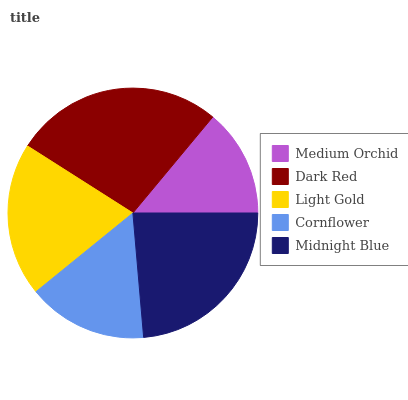Is Medium Orchid the minimum?
Answer yes or no. Yes. Is Dark Red the maximum?
Answer yes or no. Yes. Is Light Gold the minimum?
Answer yes or no. No. Is Light Gold the maximum?
Answer yes or no. No. Is Dark Red greater than Light Gold?
Answer yes or no. Yes. Is Light Gold less than Dark Red?
Answer yes or no. Yes. Is Light Gold greater than Dark Red?
Answer yes or no. No. Is Dark Red less than Light Gold?
Answer yes or no. No. Is Light Gold the high median?
Answer yes or no. Yes. Is Light Gold the low median?
Answer yes or no. Yes. Is Dark Red the high median?
Answer yes or no. No. Is Medium Orchid the low median?
Answer yes or no. No. 